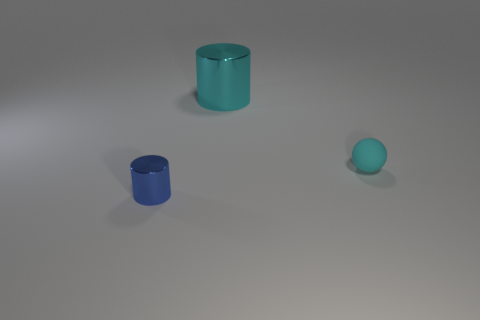Are there any small shiny cylinders on the right side of the cylinder on the right side of the metal object in front of the rubber thing?
Your answer should be very brief. No. What number of cylinders are either tiny blue metallic things or cyan things?
Make the answer very short. 2. Is the shape of the big object the same as the thing right of the large cylinder?
Ensure brevity in your answer.  No. Are there fewer tiny blue objects left of the small blue metallic object than tiny yellow matte spheres?
Provide a short and direct response. No. There is a tiny blue object; are there any cyan matte things right of it?
Ensure brevity in your answer.  Yes. Is there another thing that has the same shape as the cyan rubber object?
Your answer should be very brief. No. There is a cyan rubber thing that is the same size as the blue metal object; what is its shape?
Offer a very short reply. Sphere. How many objects are things on the right side of the large shiny object or large cyan things?
Give a very brief answer. 2. Does the matte object have the same color as the tiny metallic cylinder?
Your response must be concise. No. How big is the thing that is behind the cyan matte sphere?
Your answer should be compact. Large. 